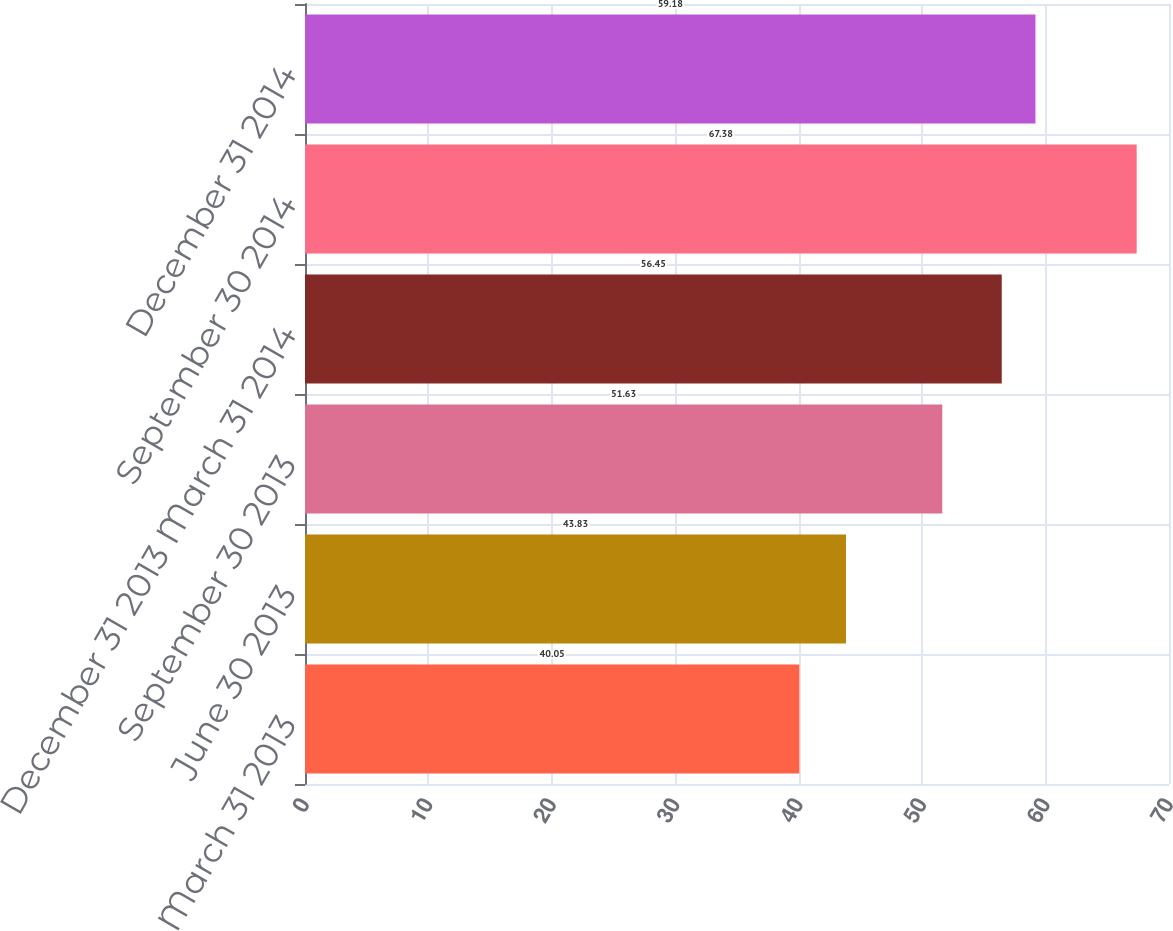Convert chart to OTSL. <chart><loc_0><loc_0><loc_500><loc_500><bar_chart><fcel>March 31 2013<fcel>June 30 2013<fcel>September 30 2013<fcel>December 31 2013 March 31 2014<fcel>September 30 2014<fcel>December 31 2014<nl><fcel>40.05<fcel>43.83<fcel>51.63<fcel>56.45<fcel>67.38<fcel>59.18<nl></chart> 